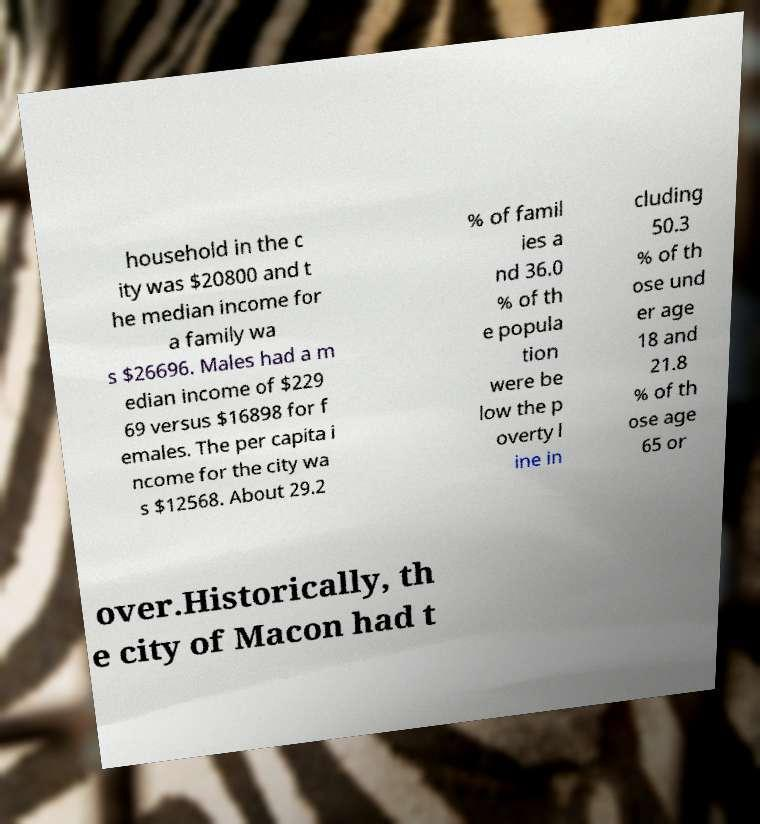Can you read and provide the text displayed in the image?This photo seems to have some interesting text. Can you extract and type it out for me? household in the c ity was $20800 and t he median income for a family wa s $26696. Males had a m edian income of $229 69 versus $16898 for f emales. The per capita i ncome for the city wa s $12568. About 29.2 % of famil ies a nd 36.0 % of th e popula tion were be low the p overty l ine in cluding 50.3 % of th ose und er age 18 and 21.8 % of th ose age 65 or over.Historically, th e city of Macon had t 